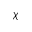Convert formula to latex. <formula><loc_0><loc_0><loc_500><loc_500>\chi</formula> 